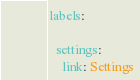Convert code to text. <code><loc_0><loc_0><loc_500><loc_500><_YAML_>labels:

  settings:
    link: Settings</code> 